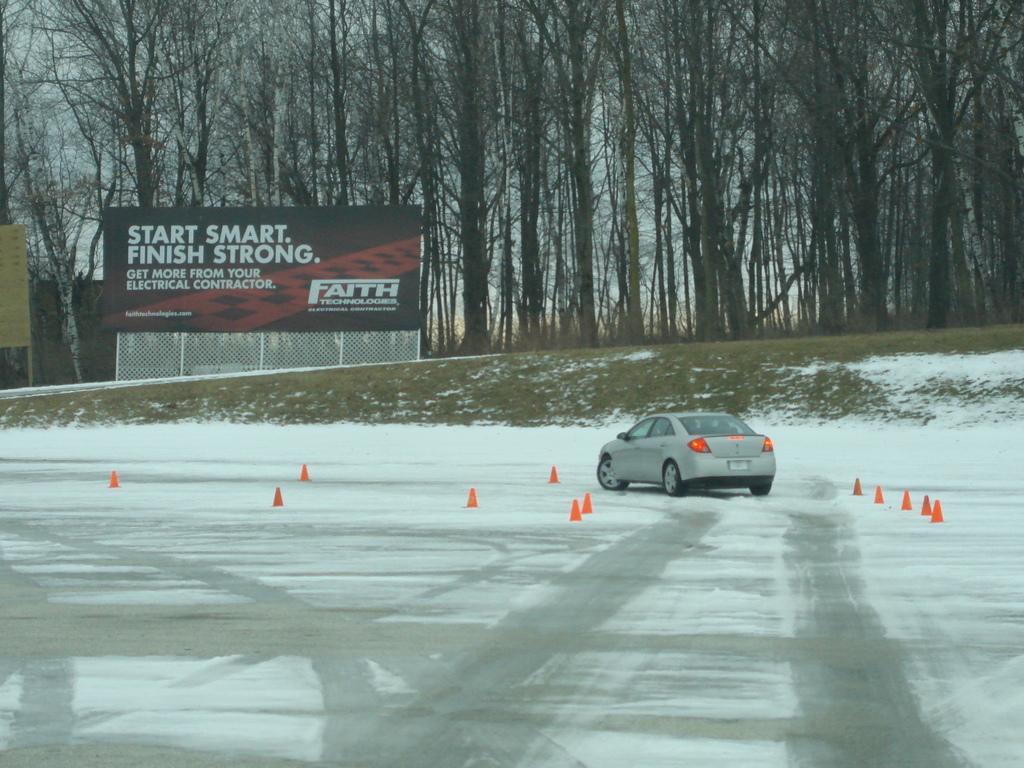Describe this image in one or two sentences. Here we can see snow and traffic cones on the road. In the background there is a vehicle on the road,fence,hoarding and on the left there is an object,trees and sky. 